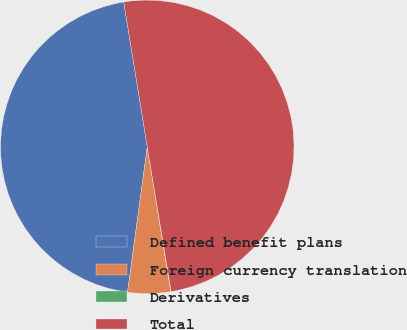Convert chart to OTSL. <chart><loc_0><loc_0><loc_500><loc_500><pie_chart><fcel>Defined benefit plans<fcel>Foreign currency translation<fcel>Derivatives<fcel>Total<nl><fcel>45.29%<fcel>4.71%<fcel>0.04%<fcel>49.96%<nl></chart> 